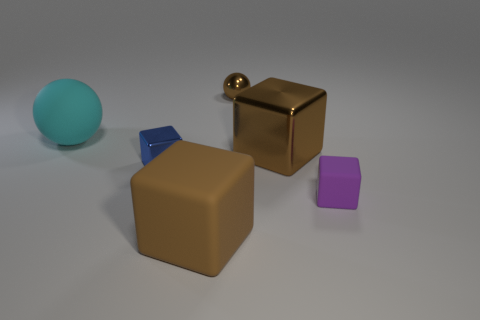Subtract all brown blocks. How many were subtracted if there are1brown blocks left? 1 Add 4 small purple blocks. How many objects exist? 10 Subtract all small purple cubes. How many cubes are left? 3 Subtract all yellow cylinders. How many brown cubes are left? 2 Subtract all brown blocks. How many blocks are left? 2 Subtract all balls. How many objects are left? 4 Subtract all tiny gray rubber things. Subtract all brown spheres. How many objects are left? 5 Add 5 tiny blue metallic objects. How many tiny blue metallic objects are left? 6 Add 3 cyan objects. How many cyan objects exist? 4 Subtract 0 green blocks. How many objects are left? 6 